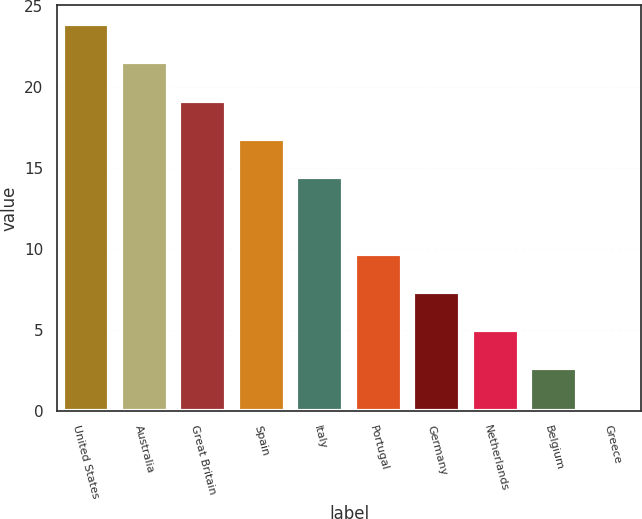Convert chart to OTSL. <chart><loc_0><loc_0><loc_500><loc_500><bar_chart><fcel>United States<fcel>Australia<fcel>Great Britain<fcel>Spain<fcel>Italy<fcel>Portugal<fcel>Germany<fcel>Netherlands<fcel>Belgium<fcel>Greece<nl><fcel>23.87<fcel>21.51<fcel>19.15<fcel>16.79<fcel>14.43<fcel>9.71<fcel>7.35<fcel>4.99<fcel>2.63<fcel>0.27<nl></chart> 